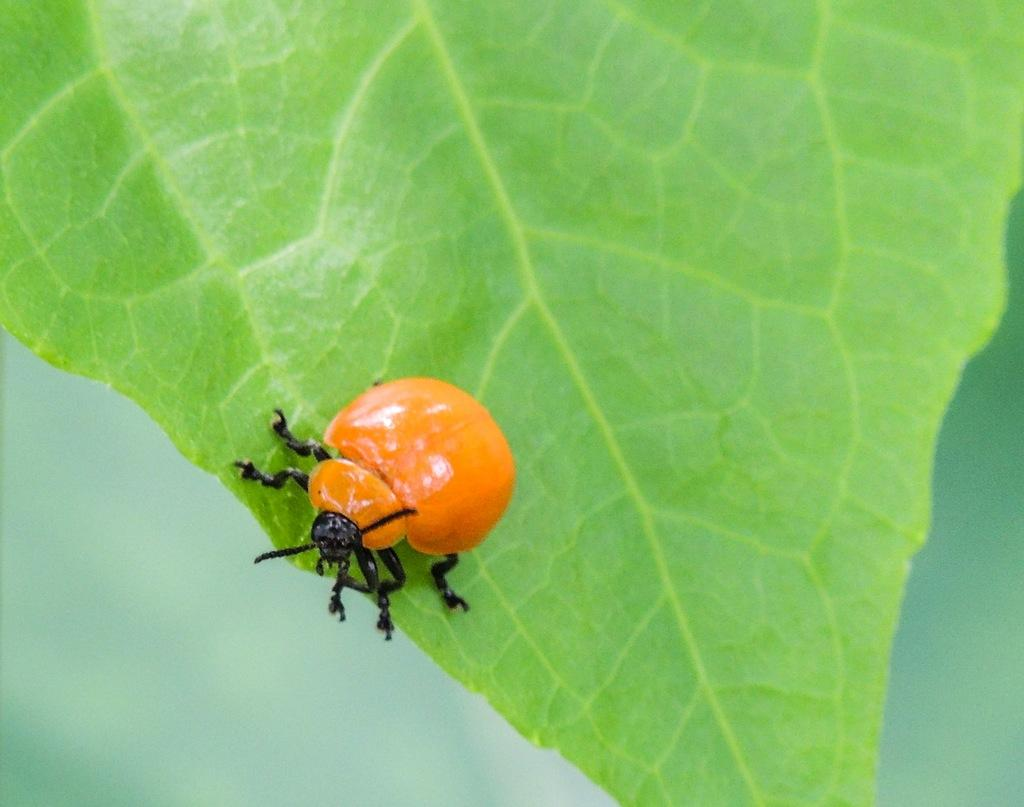What is on the green leaf in the image? There is an insect on a green leaf in the image. What color is the background of the image? The background of the image is green. What month is it in the image? The month cannot be determined from the image, as there is no information about the time of year or date. 